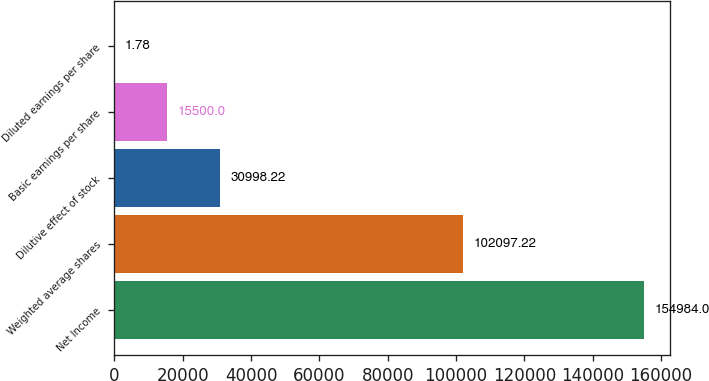Convert chart. <chart><loc_0><loc_0><loc_500><loc_500><bar_chart><fcel>Net Income<fcel>Weighted average shares<fcel>Dilutive effect of stock<fcel>Basic earnings per share<fcel>Diluted earnings per share<nl><fcel>154984<fcel>102097<fcel>30998.2<fcel>15500<fcel>1.78<nl></chart> 